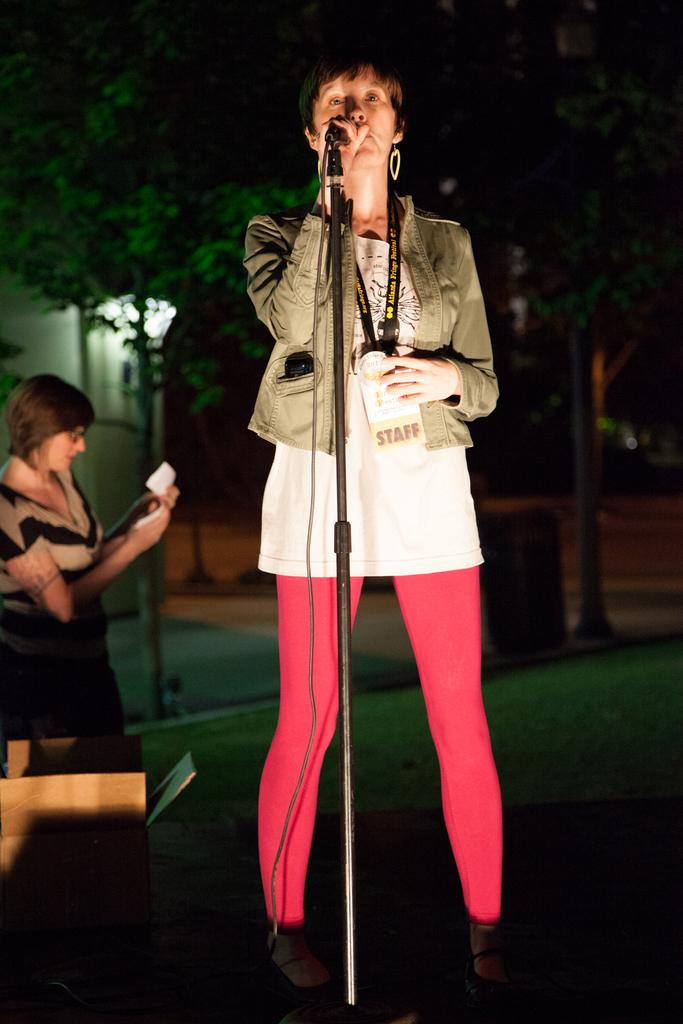What is the lady in the image holding? The lady is holding a mic. Can you describe the lady's attire? The lady is wearing a jacket and has a tag. Is there anyone else in the image besides the lady? Yes, there is another woman in the background. What object can be seen beside the lady? There is a box beside the lady. What is the plot of the story being told by the lady with the mic? There is no story being told in the image, as it is a still photograph. 